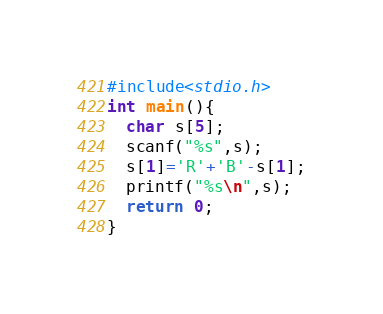Convert code to text. <code><loc_0><loc_0><loc_500><loc_500><_C_>#include<stdio.h>
int main(){
  char s[5];
  scanf("%s",s);
  s[1]='R'+'B'-s[1];
  printf("%s\n",s);
  return 0;
}
</code> 